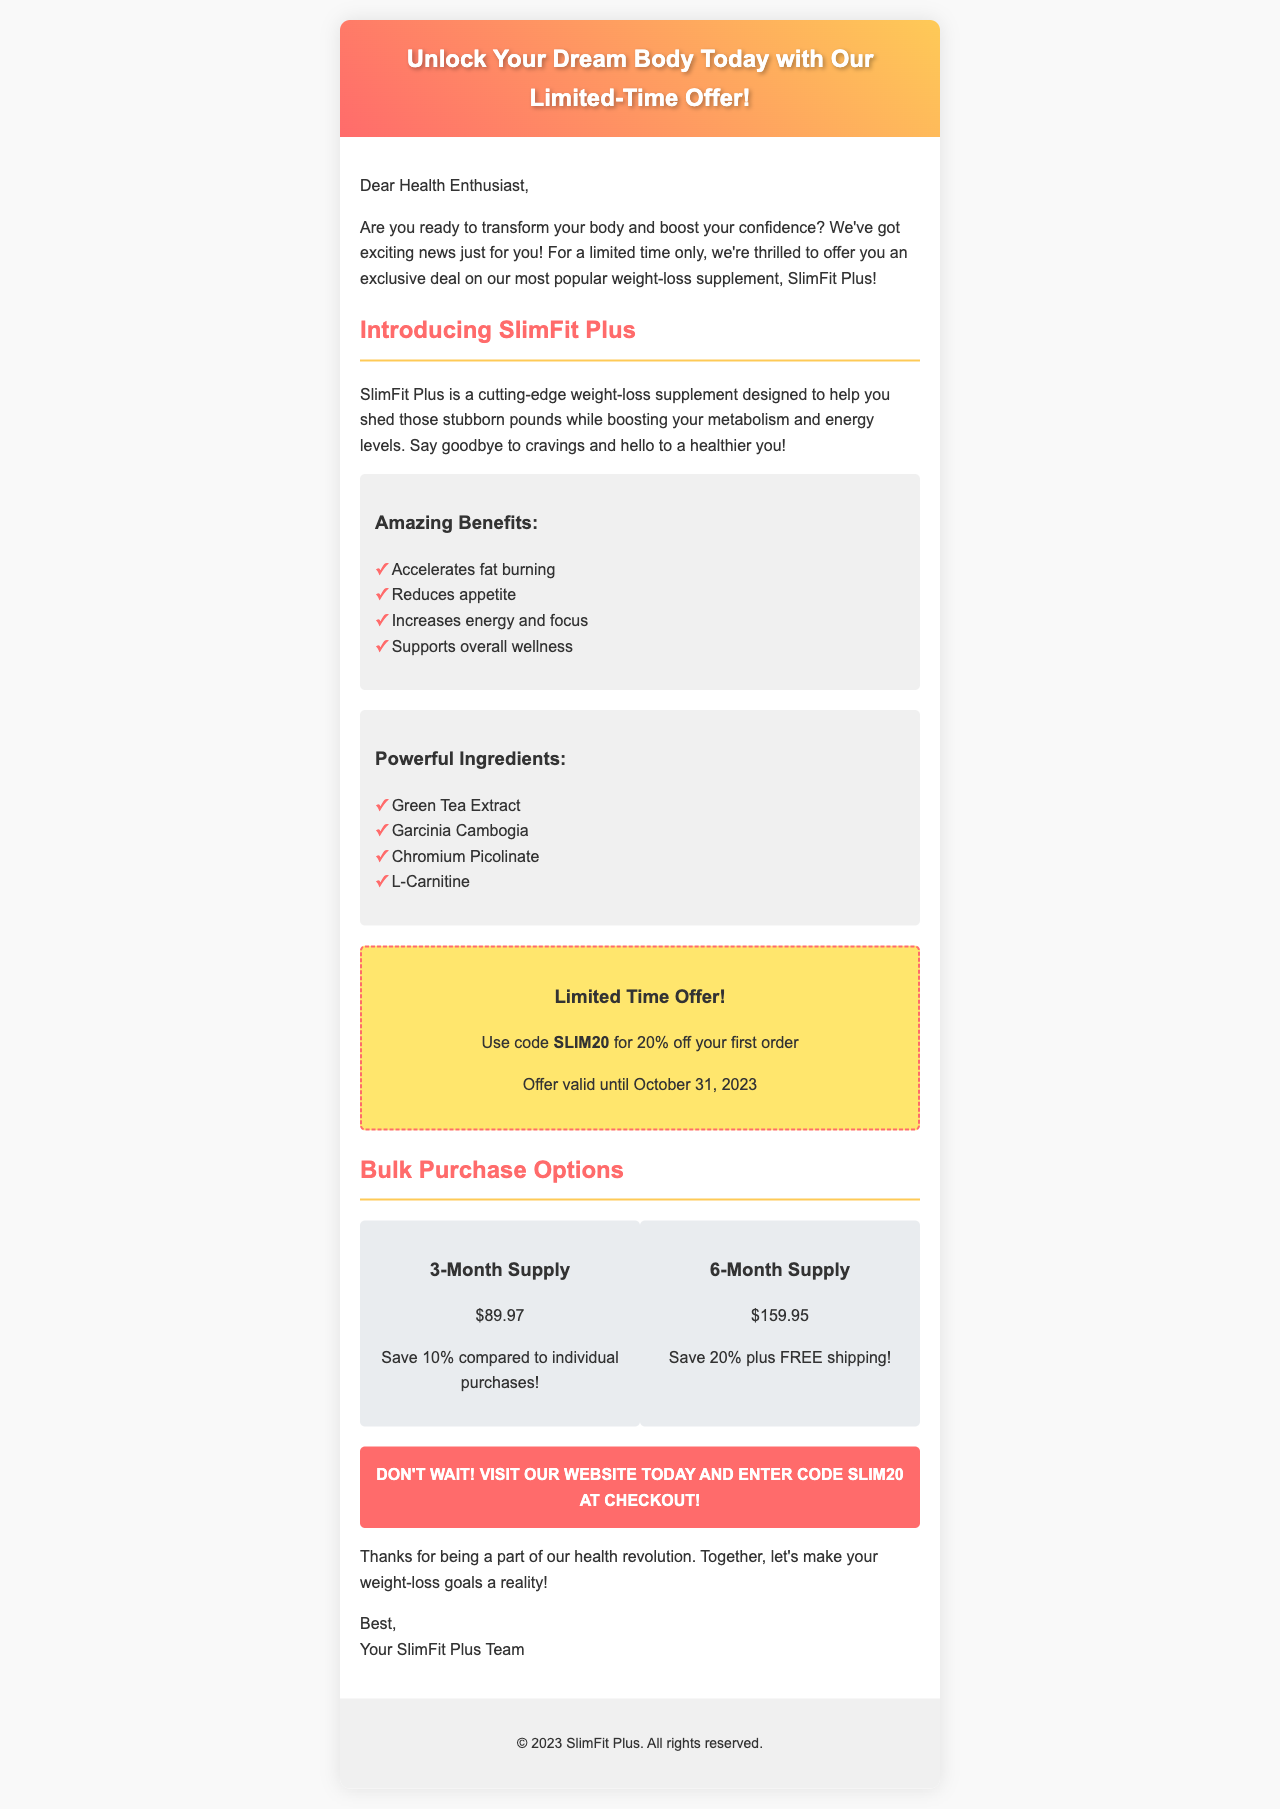What is the name of the supplement? The document specifically mentions the name of the supplement as "SlimFit Plus."
Answer: SlimFit Plus What discount code is provided? The email includes a specific discount code for orders, which is highlighted in the offer section.
Answer: SLIM20 What is the percentage off for the first order? The email states that customers can use the code to get a discount on their first purchase, which is explicitly mentioned.
Answer: 20% What is the price of the 3-month supply? The email provides the cost for the 3-month supply in the bulk purchase options section.
Answer: $89.97 When does the offer expire? The document includes a specific date until which the promotional offer is valid.
Answer: October 31, 2023 What is one of the ingredients listed in the supplement? The email lists several ingredients under a specific section dedicated to the supplement's composition.
Answer: Green Tea Extract How much can you save with the 6-month supply? The document states the savings received when purchasing the 6-month supply.
Answer: 20% What is the call to action in the email? The email concludes with a directive encouraging customers to take immediate action, signaling urgency.
Answer: Visit our website today and enter code SLIM20 at checkout! 